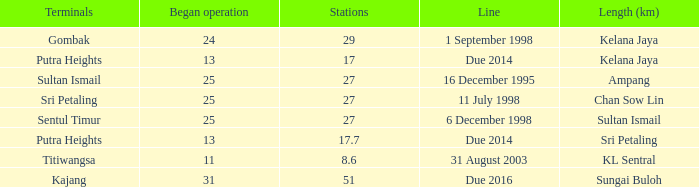When did the first initiation of operation occur with a length of sultan ismail and beyond 27 stations? None. 